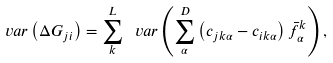Convert formula to latex. <formula><loc_0><loc_0><loc_500><loc_500>\ v a r \left ( \Delta G _ { j i } \right ) = \sum _ { k } ^ { L } \ v a r \left ( \sum _ { \alpha } ^ { D } \left ( c _ { j k \alpha } - c _ { i k \alpha } \right ) \bar { f } _ { \alpha } ^ { k } \right ) ,</formula> 